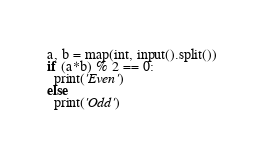<code> <loc_0><loc_0><loc_500><loc_500><_Python_>a, b = map(int, input().split())
if (a*b) % 2 == 0:
  print('Even')
else
  print('Odd')</code> 